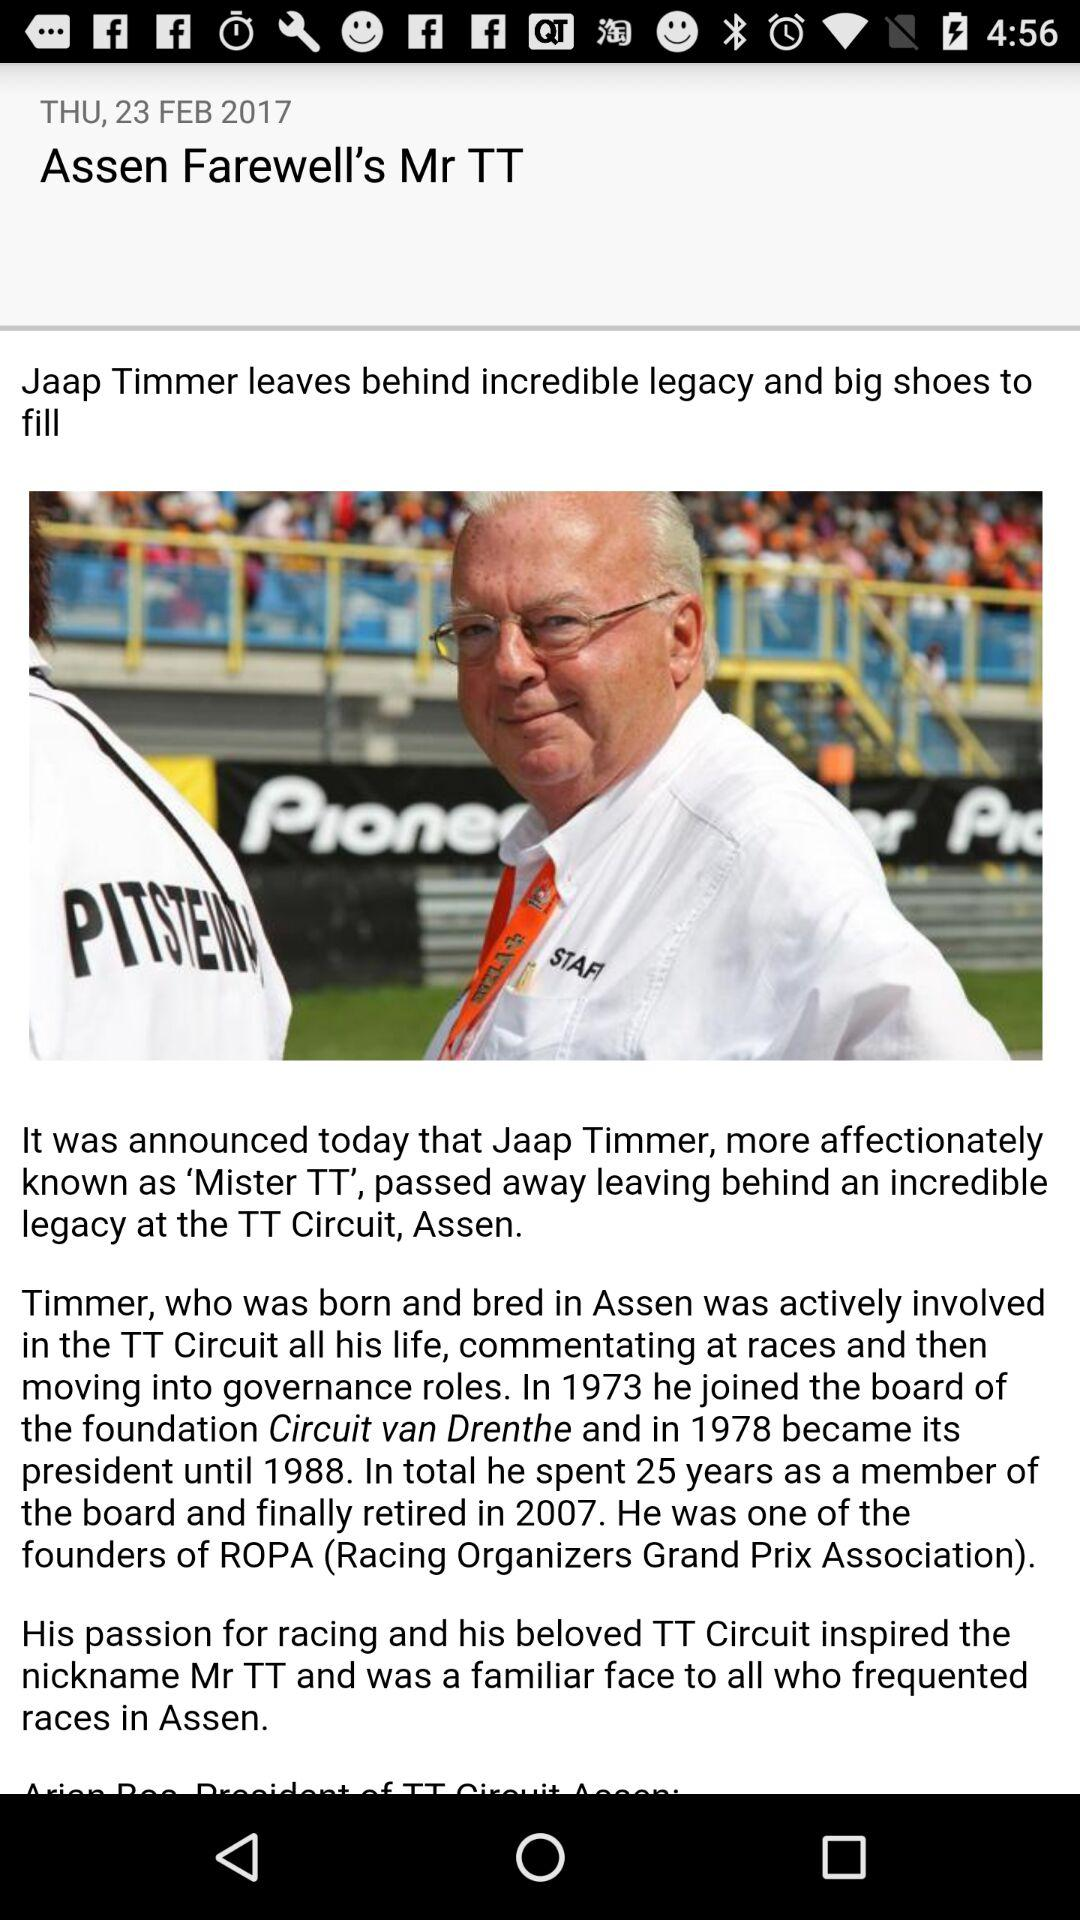When did Jaap Timmer join the board of the "Circuit van Drenthe" Foundation? Jaap Timmer joined the board in 1973. 